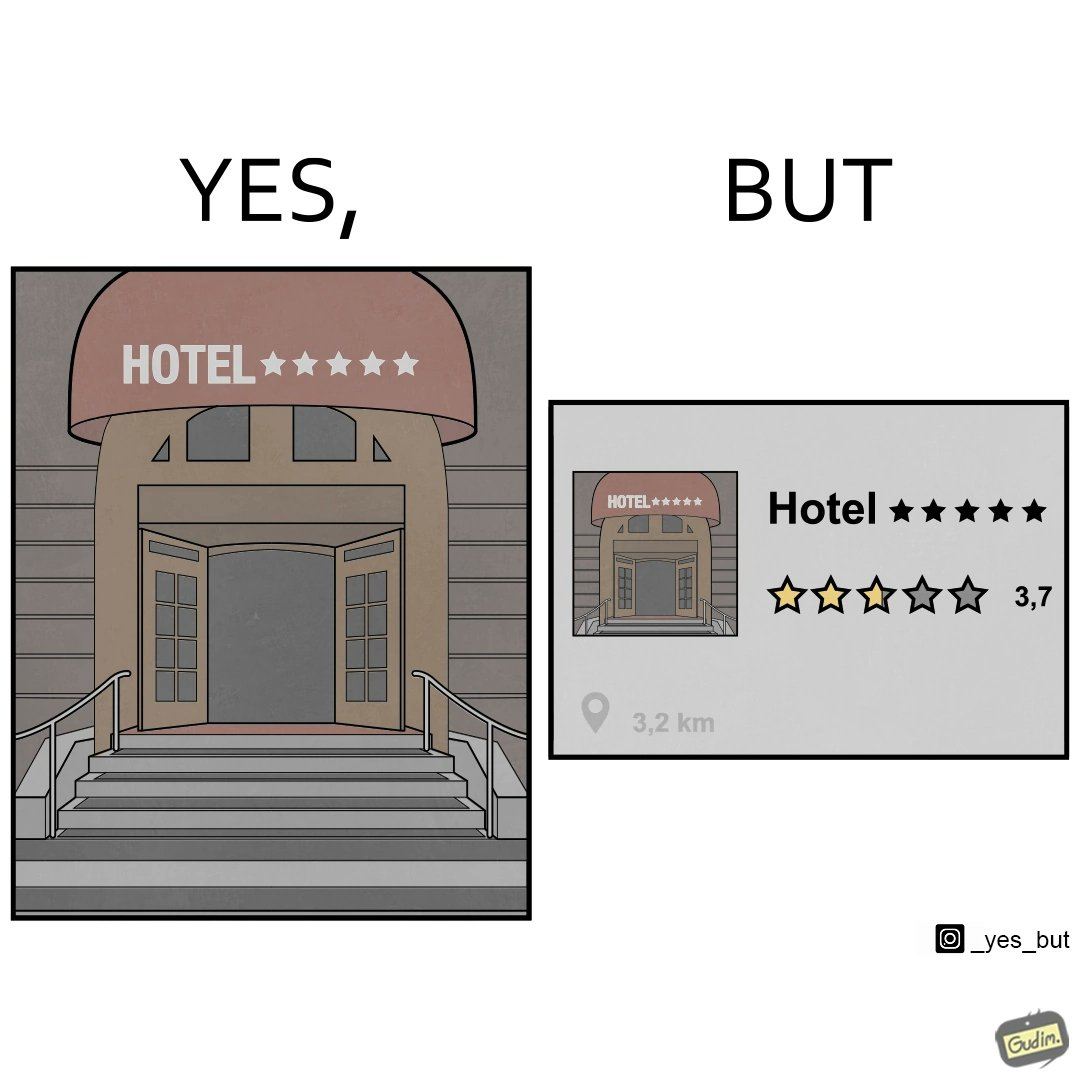Is this image satirical or non-satirical? Yes, this image is satirical. 